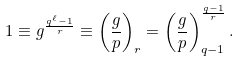Convert formula to latex. <formula><loc_0><loc_0><loc_500><loc_500>1 \equiv g ^ { \frac { q ^ { \ell } - 1 } { r } } \equiv \left ( \frac { g } { p } \right ) _ { r } = \left ( \frac { g } { p } \right ) _ { q - 1 } ^ { \frac { q - 1 } { r } } .</formula> 